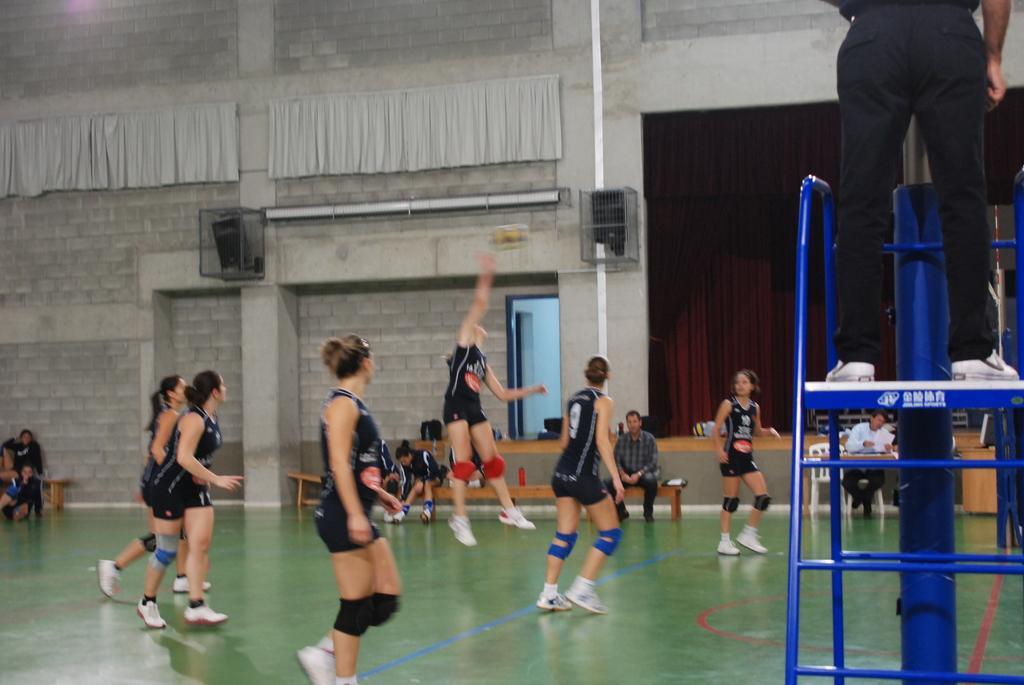Please provide a concise description of this image. In the picture we can see play floor on it we can see some women are playing a basket ball and they are in sports wear and behind them we can see a bench with a person sitting on it and behind we can see a wall with a door and beside it we can see a curtain which is brown in color. 